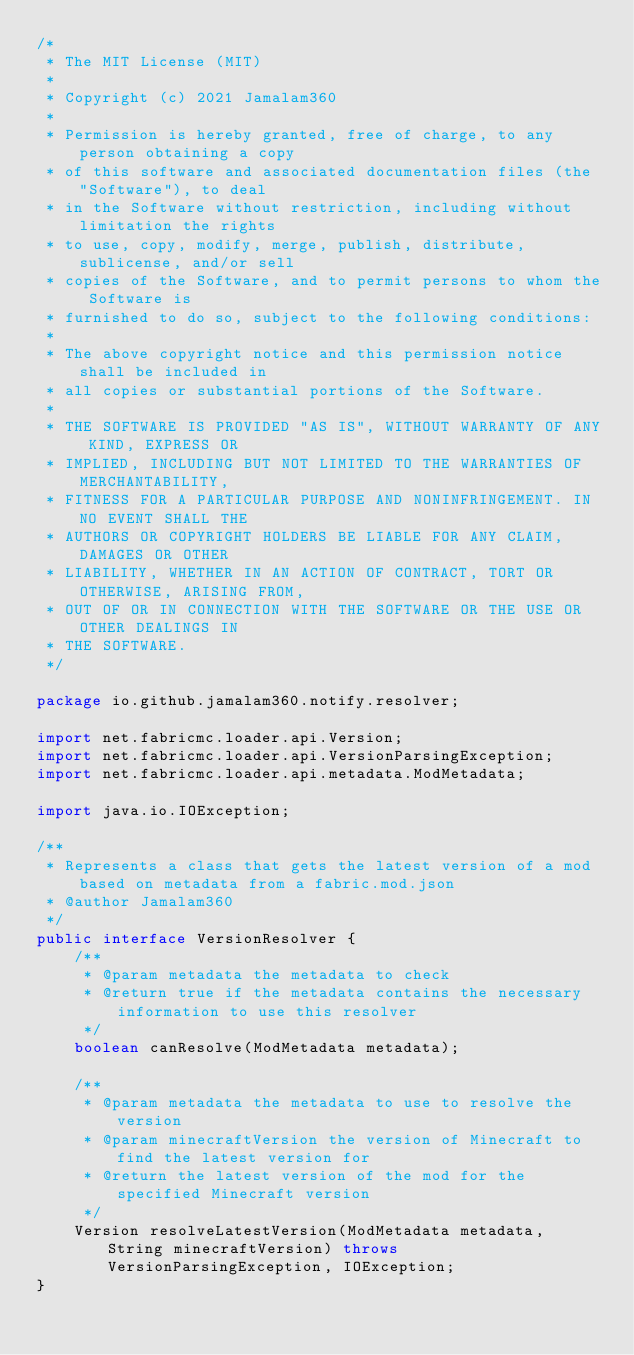<code> <loc_0><loc_0><loc_500><loc_500><_Java_>/*
 * The MIT License (MIT)
 *
 * Copyright (c) 2021 Jamalam360
 *
 * Permission is hereby granted, free of charge, to any person obtaining a copy
 * of this software and associated documentation files (the "Software"), to deal
 * in the Software without restriction, including without limitation the rights
 * to use, copy, modify, merge, publish, distribute, sublicense, and/or sell
 * copies of the Software, and to permit persons to whom the Software is
 * furnished to do so, subject to the following conditions:
 *
 * The above copyright notice and this permission notice shall be included in
 * all copies or substantial portions of the Software.
 *
 * THE SOFTWARE IS PROVIDED "AS IS", WITHOUT WARRANTY OF ANY KIND, EXPRESS OR
 * IMPLIED, INCLUDING BUT NOT LIMITED TO THE WARRANTIES OF MERCHANTABILITY,
 * FITNESS FOR A PARTICULAR PURPOSE AND NONINFRINGEMENT. IN NO EVENT SHALL THE
 * AUTHORS OR COPYRIGHT HOLDERS BE LIABLE FOR ANY CLAIM, DAMAGES OR OTHER
 * LIABILITY, WHETHER IN AN ACTION OF CONTRACT, TORT OR OTHERWISE, ARISING FROM,
 * OUT OF OR IN CONNECTION WITH THE SOFTWARE OR THE USE OR OTHER DEALINGS IN
 * THE SOFTWARE.
 */

package io.github.jamalam360.notify.resolver;

import net.fabricmc.loader.api.Version;
import net.fabricmc.loader.api.VersionParsingException;
import net.fabricmc.loader.api.metadata.ModMetadata;

import java.io.IOException;

/**
 * Represents a class that gets the latest version of a mod based on metadata from a fabric.mod.json
 * @author Jamalam360
 */
public interface VersionResolver {
    /**
     * @param metadata the metadata to check
     * @return true if the metadata contains the necessary information to use this resolver
     */
    boolean canResolve(ModMetadata metadata);

    /**
     * @param metadata the metadata to use to resolve the version
     * @param minecraftVersion the version of Minecraft to find the latest version for
     * @return the latest version of the mod for the specified Minecraft version
     */
    Version resolveLatestVersion(ModMetadata metadata, String minecraftVersion) throws VersionParsingException, IOException;
}
</code> 